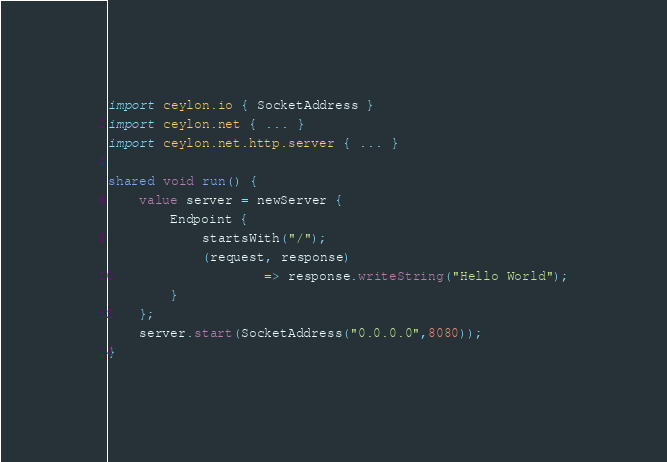Convert code to text. <code><loc_0><loc_0><loc_500><loc_500><_Ceylon_>import ceylon.io { SocketAddress }
import ceylon.net { ... }
import ceylon.net.http.server { ... }

shared void run() {
    value server = newServer {
        Endpoint {
            startsWith("/");
            (request, response) 
                    => response.writeString("Hello World");
        }
	};
	server.start(SocketAddress("0.0.0.0",8080));
}

</code> 